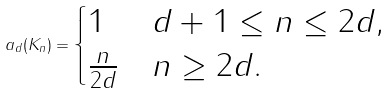Convert formula to latex. <formula><loc_0><loc_0><loc_500><loc_500>a _ { d } ( K _ { n } ) = \begin{cases} 1 & d + 1 \leq n \leq 2 d , \\ \frac { n } { 2 d } & n \geq 2 d . \end{cases}</formula> 